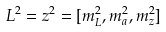Convert formula to latex. <formula><loc_0><loc_0><loc_500><loc_500>L ^ { 2 } = z ^ { 2 } = [ m _ { L } ^ { 2 } , m _ { a } ^ { 2 } , m _ { z } ^ { 2 } ]</formula> 